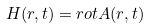Convert formula to latex. <formula><loc_0><loc_0><loc_500><loc_500>H ( r , t ) = r o t A ( r , t )</formula> 